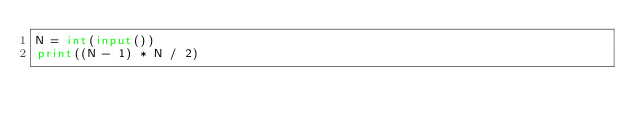Convert code to text. <code><loc_0><loc_0><loc_500><loc_500><_Python_>N = int(input())
print((N - 1) * N / 2)</code> 